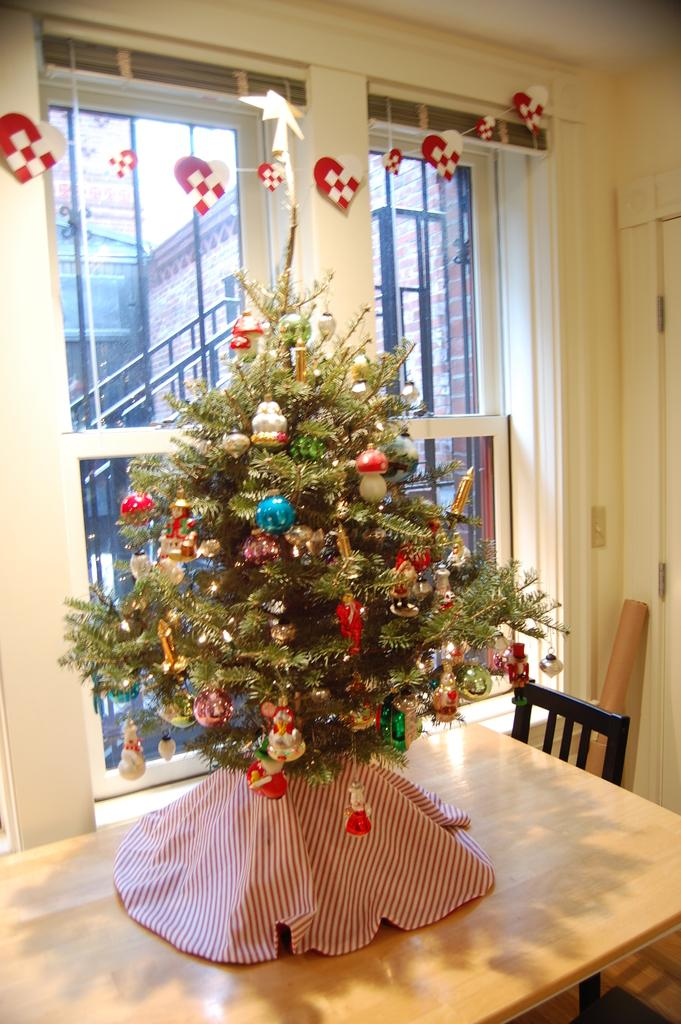What is the main object on the table in the image? There is a Christmas tree on a table in the image. What piece of furniture is located beside the table? There is a chair beside the table in the image. What can be seen through the window in the room? Buildings are visible through the window in the image. What type of net is being used for the stranger's treatment in the image? There is no stranger or treatment present in the image; it features a Christmas tree on a table with a chair beside it and a window with a view of buildings. 